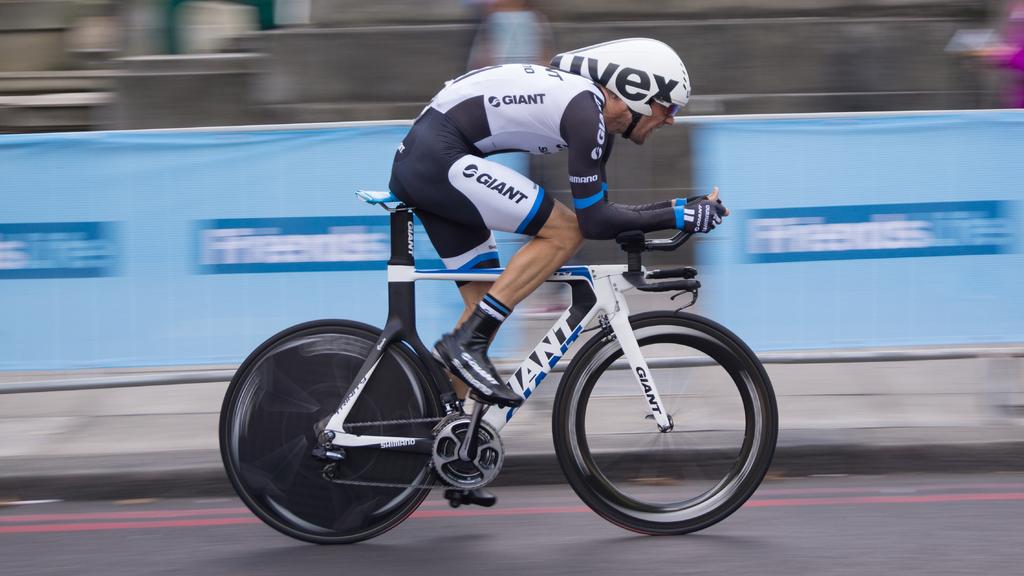What brand is the bike?
Offer a terse response. Giant. 